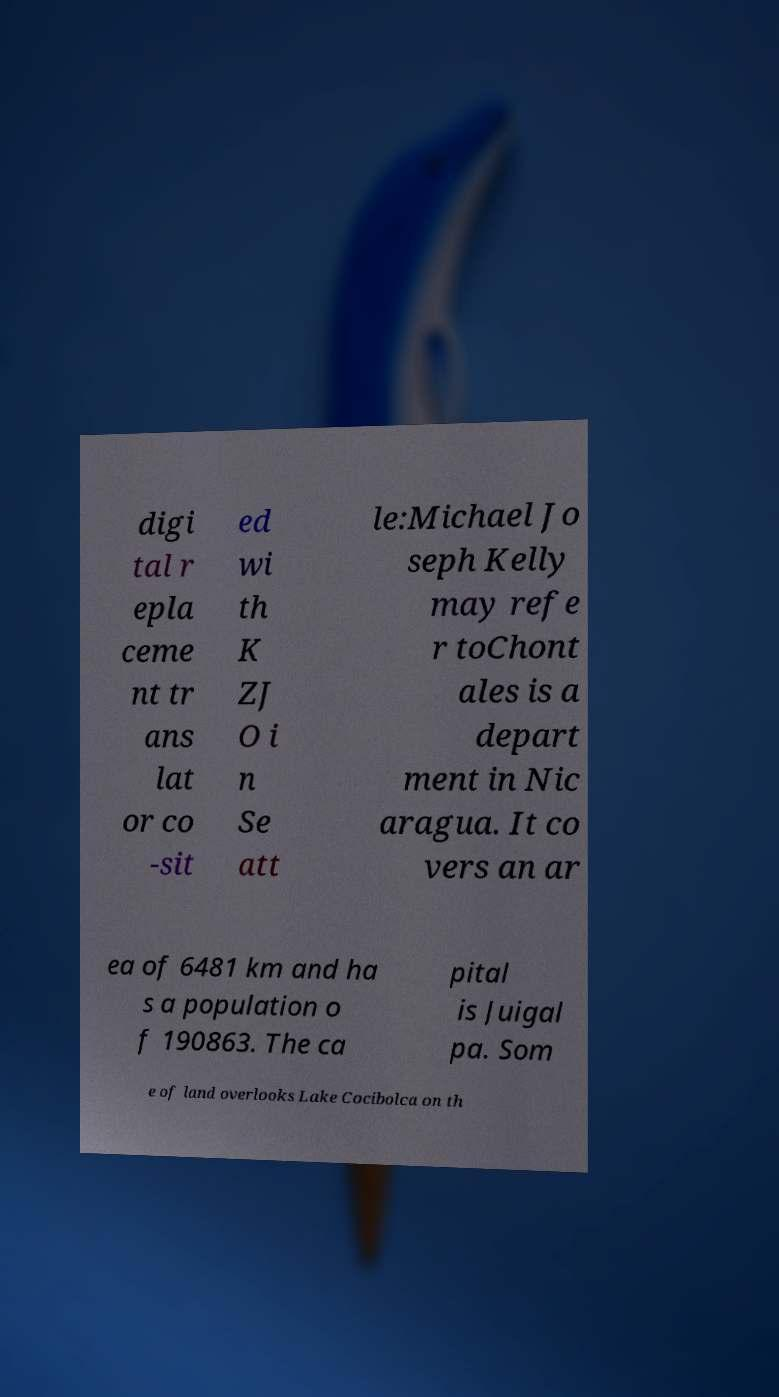What messages or text are displayed in this image? I need them in a readable, typed format. digi tal r epla ceme nt tr ans lat or co -sit ed wi th K ZJ O i n Se att le:Michael Jo seph Kelly may refe r toChont ales is a depart ment in Nic aragua. It co vers an ar ea of 6481 km and ha s a population o f 190863. The ca pital is Juigal pa. Som e of land overlooks Lake Cocibolca on th 